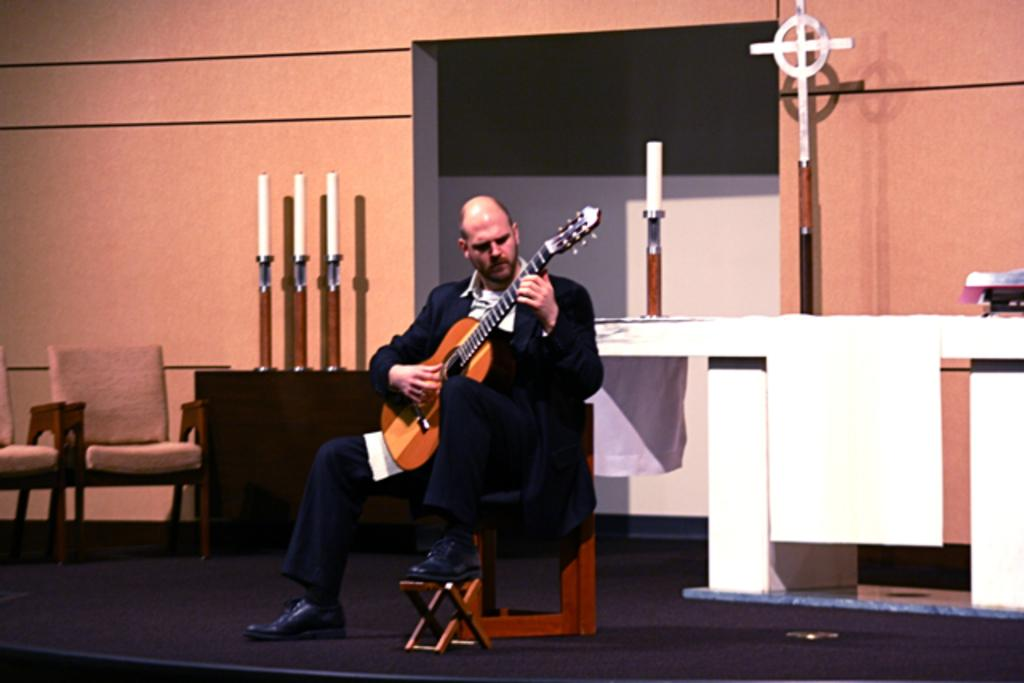What is there is a person in the image, what are they doing? The person in the image is playing a guitar. What else can be seen in the image besides the person? There are chairs, a wall, and a candle with a stand in the image. What type of achievement is the person celebrating in the image? There is no indication in the image that the person is celebrating any achievement. 